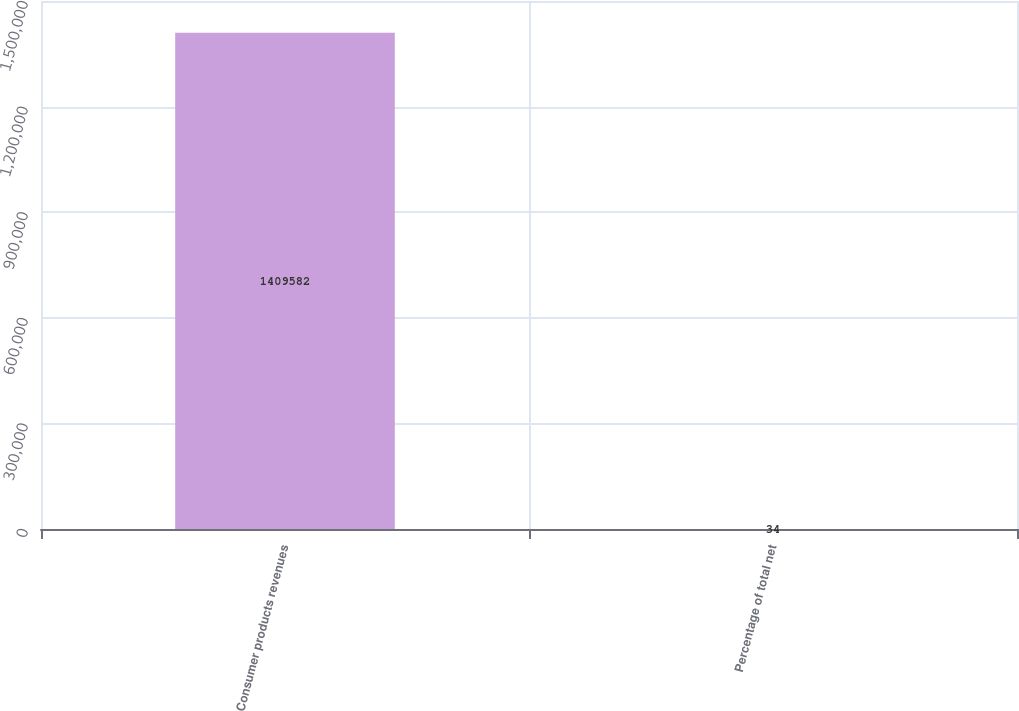Convert chart to OTSL. <chart><loc_0><loc_0><loc_500><loc_500><bar_chart><fcel>Consumer products revenues<fcel>Percentage of total net<nl><fcel>1.40958e+06<fcel>34<nl></chart> 